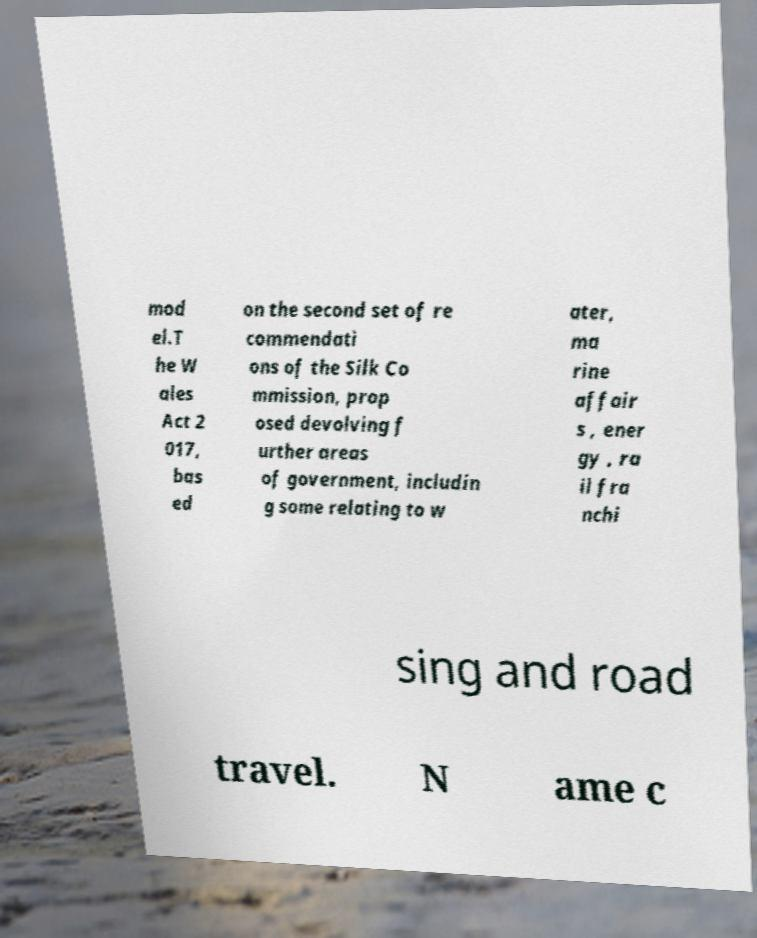Can you accurately transcribe the text from the provided image for me? mod el.T he W ales Act 2 017, bas ed on the second set of re commendati ons of the Silk Co mmission, prop osed devolving f urther areas of government, includin g some relating to w ater, ma rine affair s , ener gy , ra il fra nchi sing and road travel. N ame c 